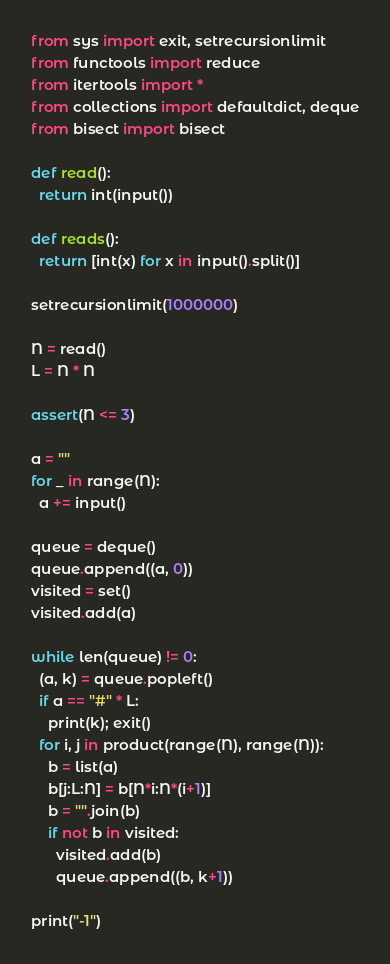Convert code to text. <code><loc_0><loc_0><loc_500><loc_500><_Python_>from sys import exit, setrecursionlimit
from functools import reduce
from itertools import *
from collections import defaultdict, deque
from bisect import bisect

def read():
  return int(input())

def reads():
  return [int(x) for x in input().split()]

setrecursionlimit(1000000)

N = read()
L = N * N

assert(N <= 3)

a = ""
for _ in range(N):
  a += input()

queue = deque()
queue.append((a, 0))
visited = set()
visited.add(a)

while len(queue) != 0:
  (a, k) = queue.popleft()
  if a == "#" * L:
    print(k); exit()
  for i, j in product(range(N), range(N)):
    b = list(a)
    b[j:L:N] = b[N*i:N*(i+1)]
    b = "".join(b)
    if not b in visited:
      visited.add(b)
      queue.append((b, k+1))

print("-1")
</code> 